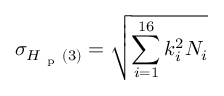Convert formula to latex. <formula><loc_0><loc_0><loc_500><loc_500>\sigma _ { H _ { p } ( 3 ) } = \sqrt { \sum _ { i = 1 } ^ { 1 6 } k _ { i } ^ { 2 } N _ { i } }</formula> 